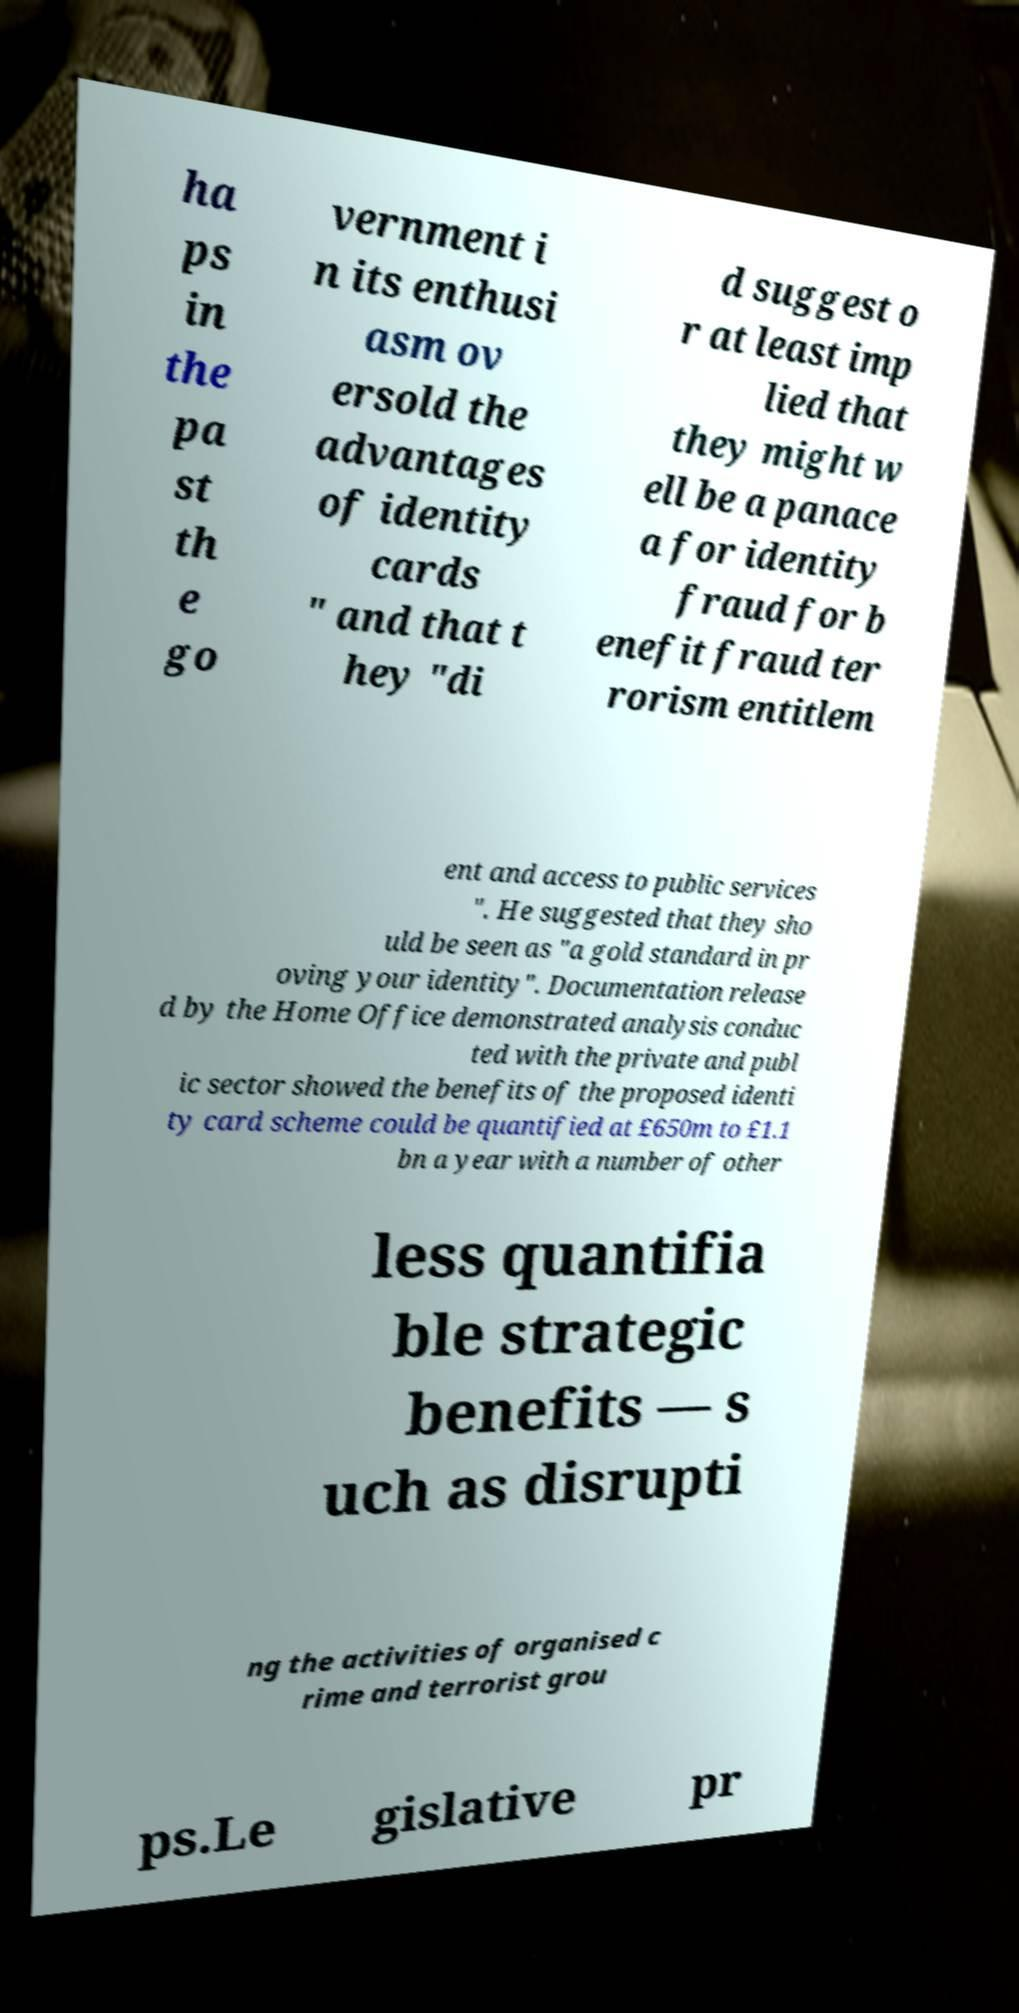Can you accurately transcribe the text from the provided image for me? ha ps in the pa st th e go vernment i n its enthusi asm ov ersold the advantages of identity cards " and that t hey "di d suggest o r at least imp lied that they might w ell be a panace a for identity fraud for b enefit fraud ter rorism entitlem ent and access to public services ". He suggested that they sho uld be seen as "a gold standard in pr oving your identity". Documentation release d by the Home Office demonstrated analysis conduc ted with the private and publ ic sector showed the benefits of the proposed identi ty card scheme could be quantified at £650m to £1.1 bn a year with a number of other less quantifia ble strategic benefits — s uch as disrupti ng the activities of organised c rime and terrorist grou ps.Le gislative pr 